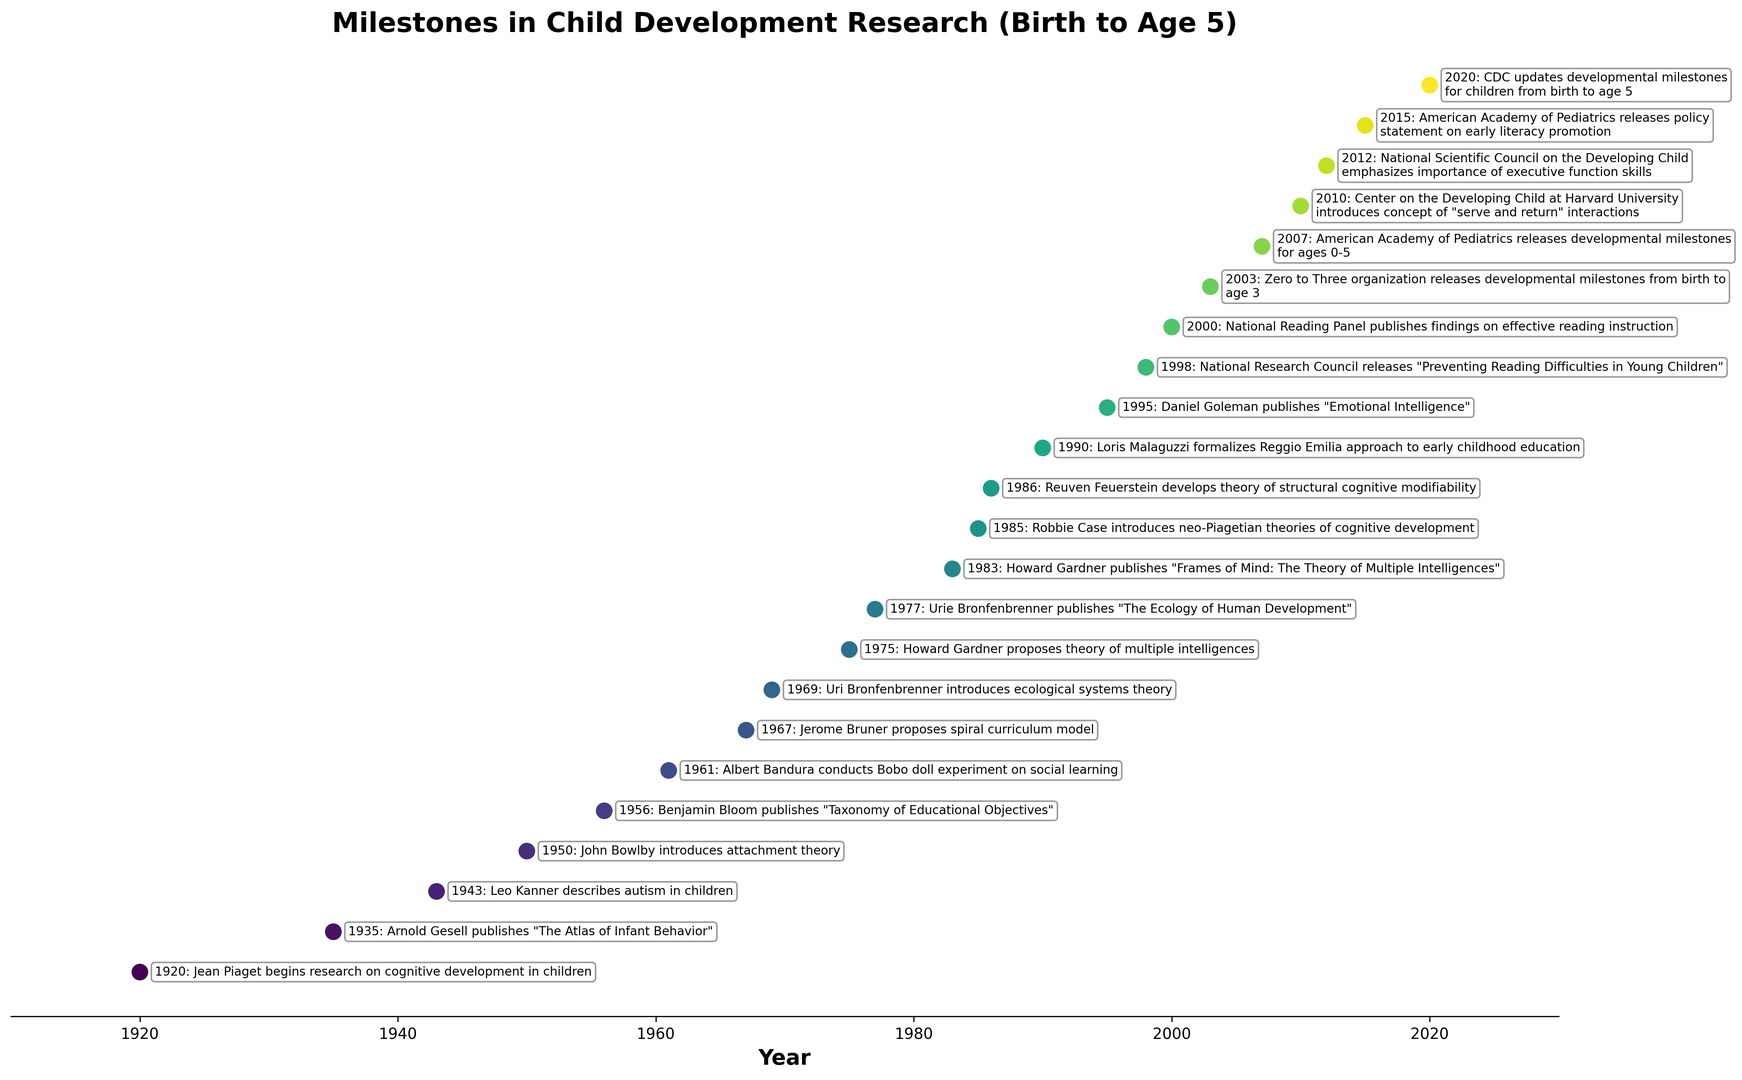What is the time span between the first and the last milestone on the plot? The first milestone is in 1920, and the last milestone is in 2020. The difference between 2020 and 1920 is 100 years.
Answer: 100 years Which milestone occurred most recently according to the plot? By inspecting the timeline, the most recent milestone is in 2020 when the CDC updates developmental milestones for children from birth to age 5.
Answer: CDC updates developmental milestones for children from birth to age 5 How many milestones were recorded after the year 2000? The milestones after 2000 are in 2003, 2007, 2010, 2012, 2015, and 2020. By counting these entries, we get 6 milestones.
Answer: 6 milestones Which milestones are related to theories on cognitive development? Cognitive development-related milestones include research by Jean Piaget in 1920, neo-Piagetian theories by Robbie Case in 1985, and structural cognitive modifiability by Reuven Feuerstein in 1986.
Answer: Jean Piaget (1920), Robbie Case (1985), Reuven Feuerstein (1986) Between 1960 and 1980, which researcher introduced the concept of attachment theory? Within this time frame, the plot shows that John Bowlby introduced attachment theory in 1950.
Answer: John Bowlby in 1950 Identify the event marked by the earliest milestone on the plot. The earliest milestone in the plot, which occurs in 1920, is Jean Piaget beginning research on cognitive development in children.
Answer: Jean Piaget begins research on cognitive development in children Which milestone related to reading difficulties or instruction was published first? The earliest publication related to reading is the 1998 "Preventing Reading Difficulties in Young Children" by National Research Council.
Answer: Preventing Reading Difficulties in Young Children (1998) What is the average year of the milestones listed on the plot? To find the average year, first sum up all the years and divide by the number of events. Sum of years: 1920+1935+...+2020 = 38317 (sum of all event years). Number of events: 21. Average year = 38317 / 21 ≈ 1823.29
Answer: ~1823 Which event appears earlier: "Albert Bandura conducts Bobo doll experiment" or "John Bowlby introduces attachment theory"? According to the plot, John Bowlby's attachment theory in 1950 is earlier than Albert Bandura's Bobo doll experiment in 1961.
Answer: John Bowlby introduces attachment theory How many milestones before the 1980s were related to theories or concepts introduced by new researchers? Before 1980, the milestones introducing new theories/concepts include works by Jean Piaget (1920), Arnold Gesell (1935), Leo Kanner (1943), John Bowlby (1950), Benjamin Bloom (1956), and Albert Bandura (1961). By counting these, we get 6 milestones.
Answer: 6 milestones 